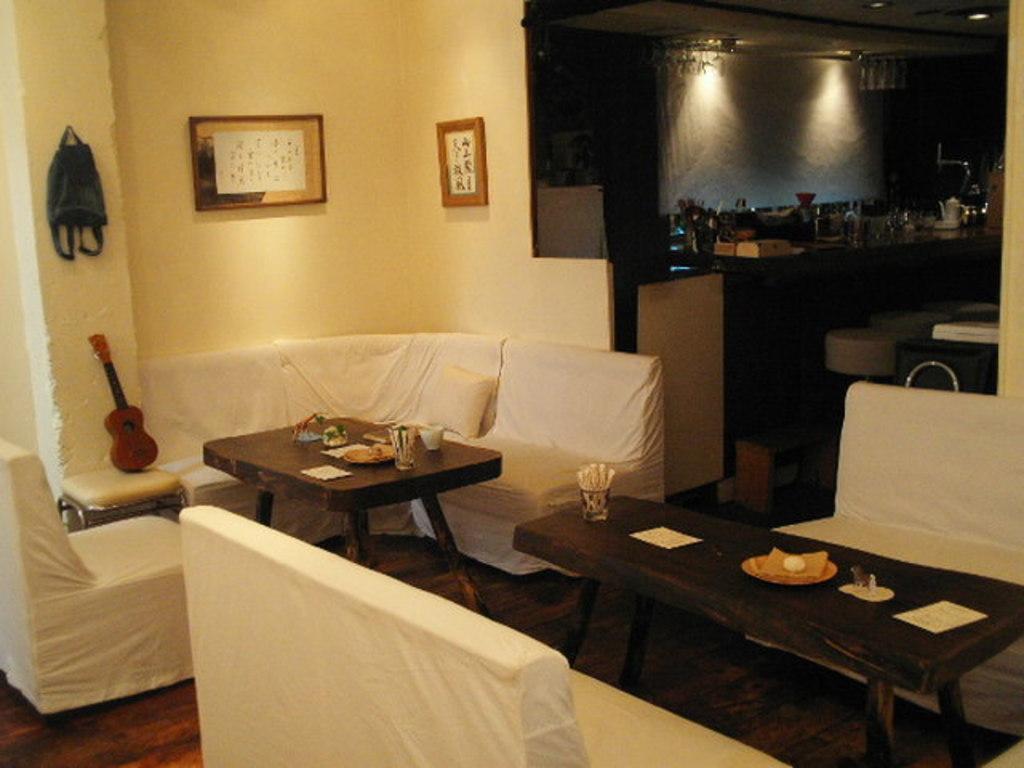How would you summarize this image in a sentence or two? In this image we can see chairs, tables. There is a wall with photo frames. There is a platform on which there are objects. At the bottom of the image there is wooden flooring. 